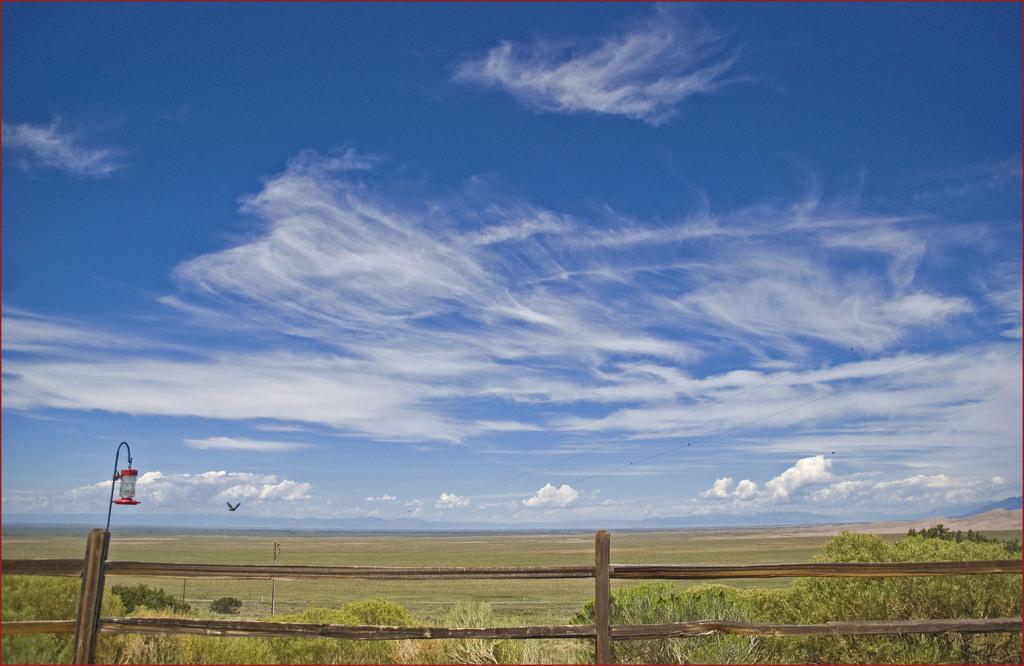Can you describe this image briefly? In the center of the image we can see the sky, clouds, grass, plants, one bird flying, poles, one lamp, fence etc. 